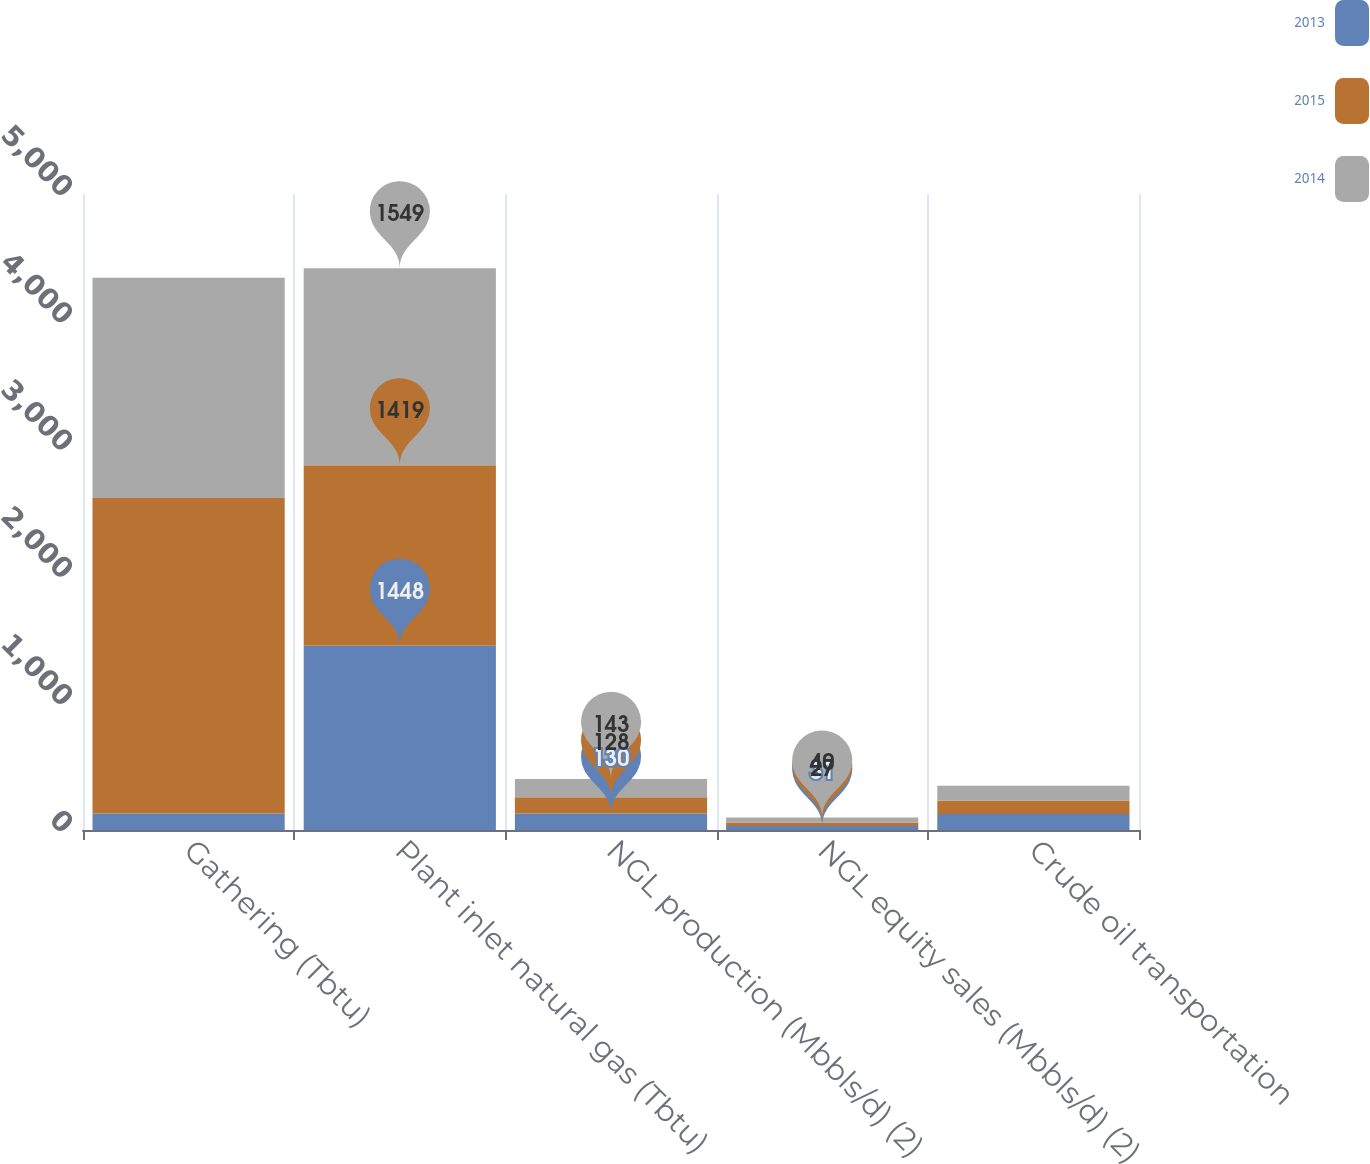Convert chart to OTSL. <chart><loc_0><loc_0><loc_500><loc_500><stacked_bar_chart><ecel><fcel>Gathering (Tbtu)<fcel>Plant inlet natural gas (Tbtu)<fcel>NGL production (Mbbls/d) (2)<fcel>NGL equity sales (Mbbls/d) (2)<fcel>Crude oil transportation<nl><fcel>2013<fcel>129<fcel>1448<fcel>130<fcel>31<fcel>126<nl><fcel>2015<fcel>2482<fcel>1419<fcel>128<fcel>27<fcel>105<nl><fcel>2014<fcel>1731<fcel>1549<fcel>143<fcel>40<fcel>117<nl></chart> 